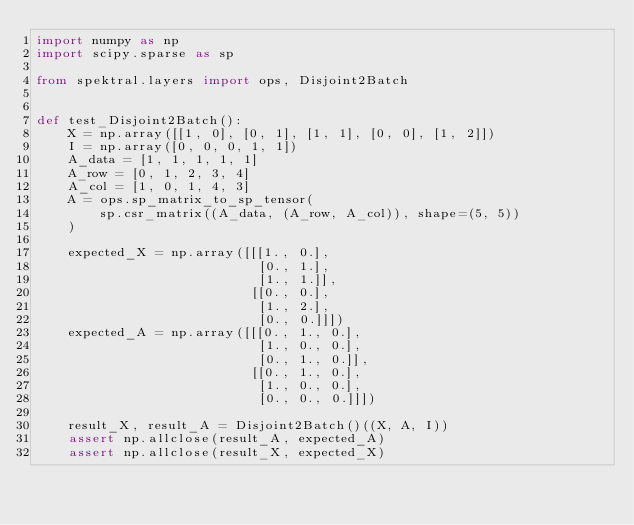<code> <loc_0><loc_0><loc_500><loc_500><_Python_>import numpy as np
import scipy.sparse as sp

from spektral.layers import ops, Disjoint2Batch


def test_Disjoint2Batch():
    X = np.array([[1, 0], [0, 1], [1, 1], [0, 0], [1, 2]])
    I = np.array([0, 0, 0, 1, 1])
    A_data = [1, 1, 1, 1, 1]
    A_row = [0, 1, 2, 3, 4]
    A_col = [1, 0, 1, 4, 3]
    A = ops.sp_matrix_to_sp_tensor(
        sp.csr_matrix((A_data, (A_row, A_col)), shape=(5, 5))
    )

    expected_X = np.array([[[1., 0.],
                            [0., 1.],
                            [1., 1.]],
                           [[0., 0.],
                            [1., 2.],
                            [0., 0.]]])
    expected_A = np.array([[[0., 1., 0.],
                            [1., 0., 0.],
                            [0., 1., 0.]],
                           [[0., 1., 0.],
                            [1., 0., 0.],
                            [0., 0., 0.]]])

    result_X, result_A = Disjoint2Batch()((X, A, I))
    assert np.allclose(result_A, expected_A)
    assert np.allclose(result_X, expected_X)
</code> 